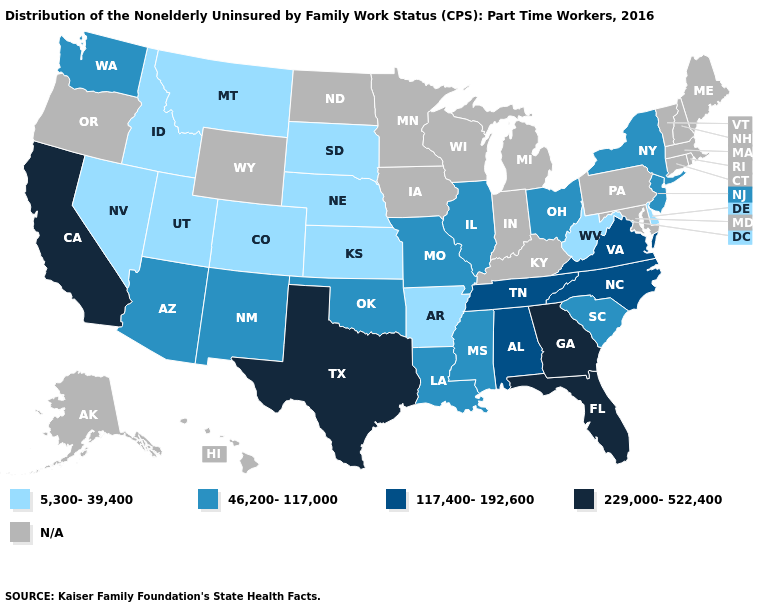What is the value of Mississippi?
Keep it brief. 46,200-117,000. What is the value of Minnesota?
Write a very short answer. N/A. Does the map have missing data?
Give a very brief answer. Yes. Name the states that have a value in the range 117,400-192,600?
Concise answer only. Alabama, North Carolina, Tennessee, Virginia. Among the states that border Maryland , which have the lowest value?
Be succinct. Delaware, West Virginia. What is the lowest value in the USA?
Write a very short answer. 5,300-39,400. What is the lowest value in states that border Kansas?
Write a very short answer. 5,300-39,400. What is the value of South Carolina?
Write a very short answer. 46,200-117,000. Among the states that border Virginia , which have the highest value?
Short answer required. North Carolina, Tennessee. Name the states that have a value in the range N/A?
Answer briefly. Alaska, Connecticut, Hawaii, Indiana, Iowa, Kentucky, Maine, Maryland, Massachusetts, Michigan, Minnesota, New Hampshire, North Dakota, Oregon, Pennsylvania, Rhode Island, Vermont, Wisconsin, Wyoming. What is the value of Maryland?
Be succinct. N/A. Name the states that have a value in the range 5,300-39,400?
Write a very short answer. Arkansas, Colorado, Delaware, Idaho, Kansas, Montana, Nebraska, Nevada, South Dakota, Utah, West Virginia. Which states have the lowest value in the West?
Be succinct. Colorado, Idaho, Montana, Nevada, Utah. Name the states that have a value in the range N/A?
Write a very short answer. Alaska, Connecticut, Hawaii, Indiana, Iowa, Kentucky, Maine, Maryland, Massachusetts, Michigan, Minnesota, New Hampshire, North Dakota, Oregon, Pennsylvania, Rhode Island, Vermont, Wisconsin, Wyoming. Which states have the highest value in the USA?
Write a very short answer. California, Florida, Georgia, Texas. 